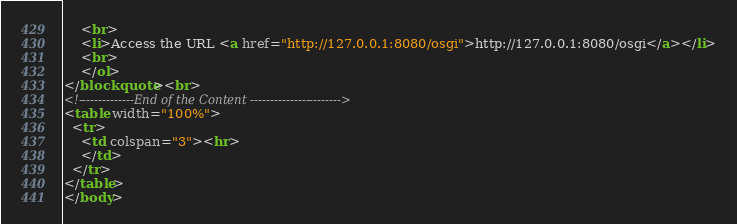Convert code to text. <code><loc_0><loc_0><loc_500><loc_500><_HTML_>	<br>
	<li>Access the URL <a href="http://127.0.0.1:8080/osgi">http://127.0.0.1:8080/osgi</a></li>
	<br>
	</ol>
</blockquote><br>
<!--------------End of the Content ----------------------->
<table width="100%">
  <tr>
    <td colspan="3"><hr>
    </td>
  </tr>
</table>
</body>
</code> 